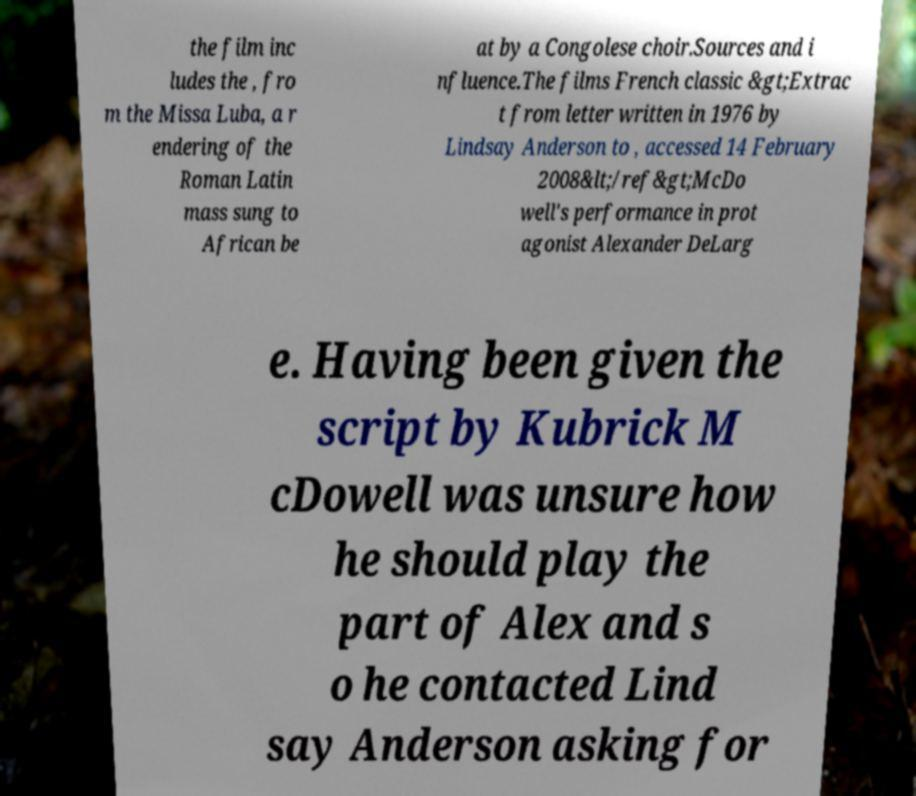Please read and relay the text visible in this image. What does it say? the film inc ludes the , fro m the Missa Luba, a r endering of the Roman Latin mass sung to African be at by a Congolese choir.Sources and i nfluence.The films French classic &gt;Extrac t from letter written in 1976 by Lindsay Anderson to , accessed 14 February 2008&lt;/ref&gt;McDo well's performance in prot agonist Alexander DeLarg e. Having been given the script by Kubrick M cDowell was unsure how he should play the part of Alex and s o he contacted Lind say Anderson asking for 